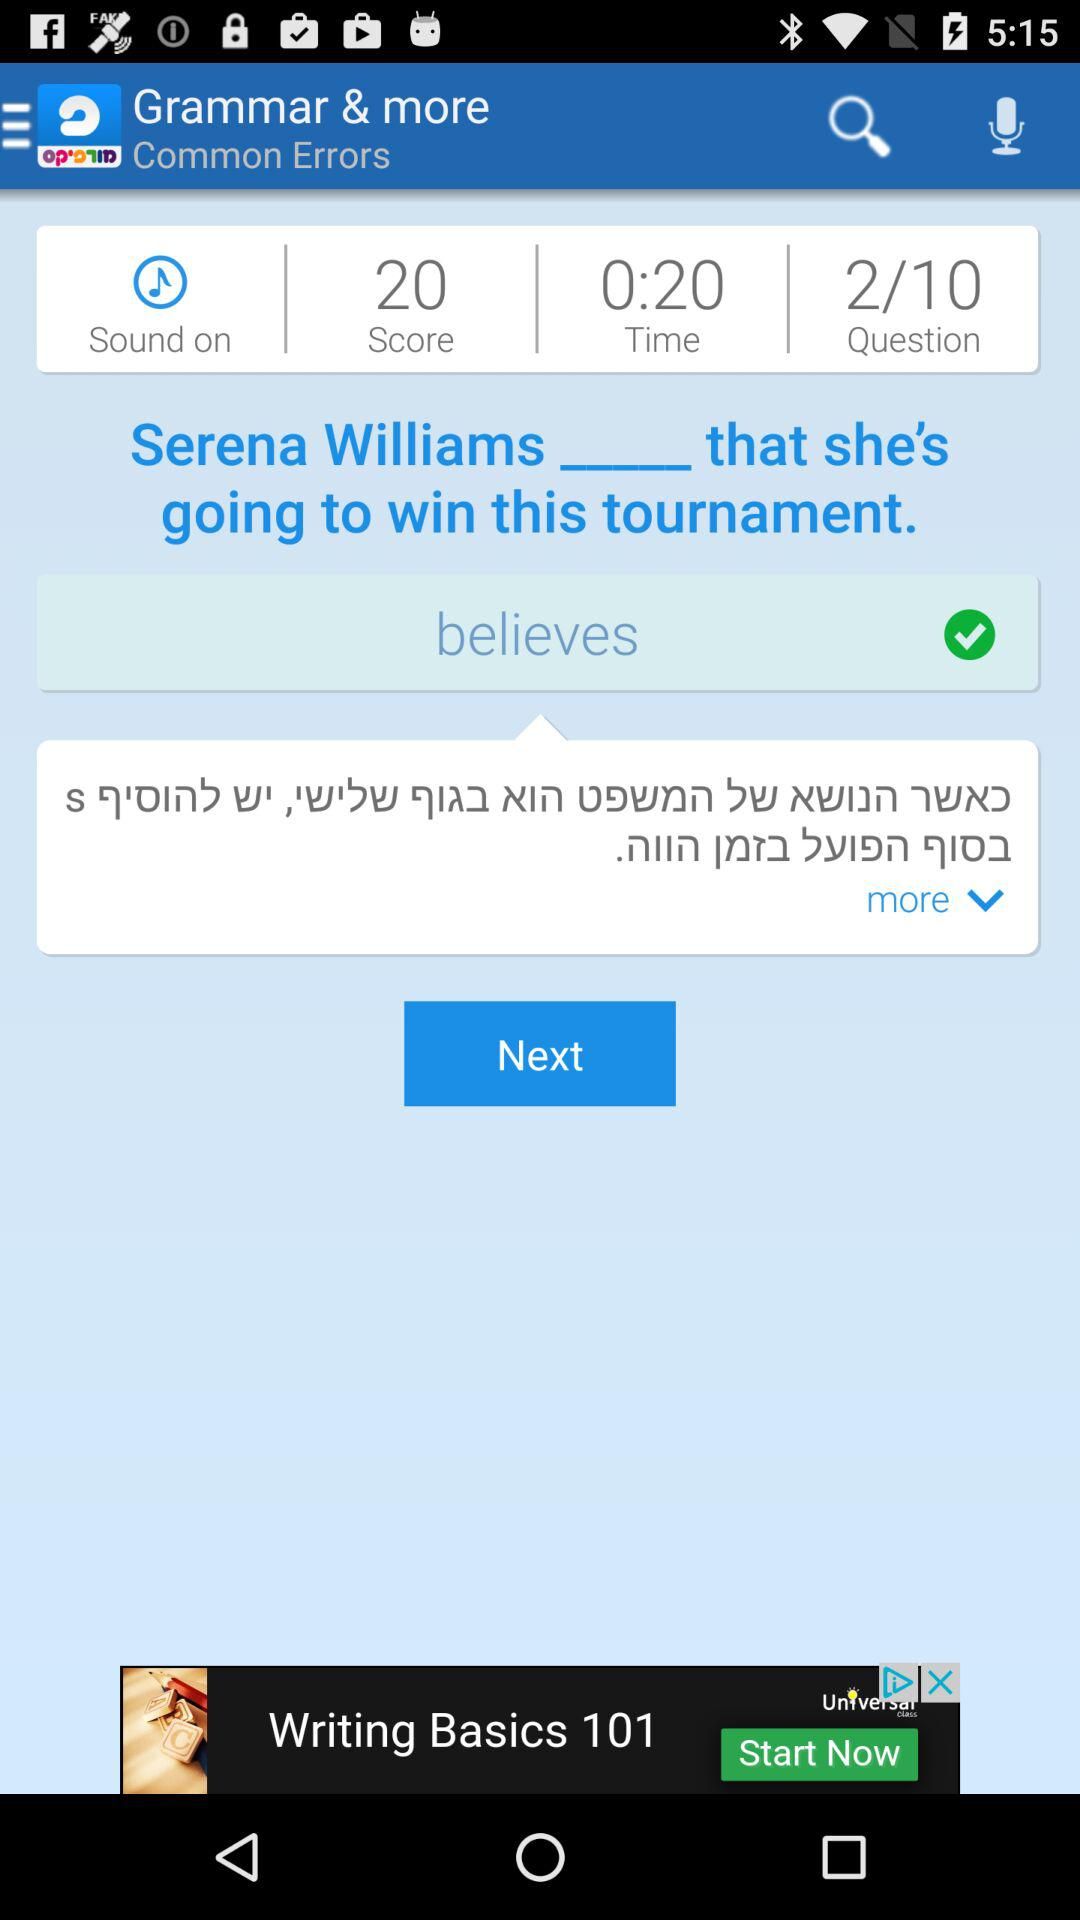What's the status of "Sound"? The status is "on". 